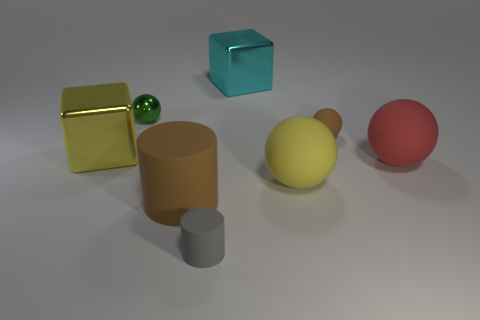Subtract all small brown spheres. How many spheres are left? 3 Subtract 1 balls. How many balls are left? 3 Add 1 brown rubber cylinders. How many objects exist? 9 Subtract all blue balls. Subtract all yellow cylinders. How many balls are left? 4 Subtract 0 cyan spheres. How many objects are left? 8 Subtract all cubes. How many objects are left? 6 Subtract all matte spheres. Subtract all tiny blue things. How many objects are left? 5 Add 5 big metallic cubes. How many big metallic cubes are left? 7 Add 3 gray objects. How many gray objects exist? 4 